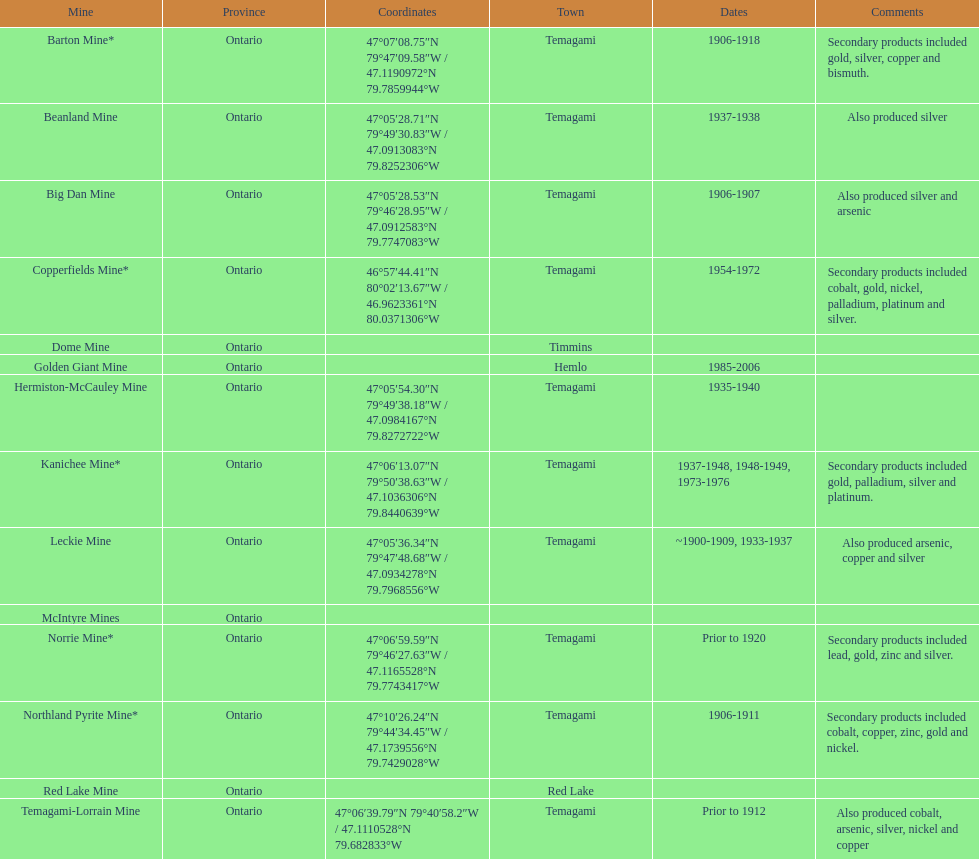Could you help me parse every detail presented in this table? {'header': ['Mine', 'Province', 'Coordinates', 'Town', 'Dates', 'Comments'], 'rows': [['Barton Mine*', 'Ontario', '47°07′08.75″N 79°47′09.58″W\ufeff / \ufeff47.1190972°N 79.7859944°W', 'Temagami', '1906-1918', 'Secondary products included gold, silver, copper and bismuth.'], ['Beanland Mine', 'Ontario', '47°05′28.71″N 79°49′30.83″W\ufeff / \ufeff47.0913083°N 79.8252306°W', 'Temagami', '1937-1938', 'Also produced silver'], ['Big Dan Mine', 'Ontario', '47°05′28.53″N 79°46′28.95″W\ufeff / \ufeff47.0912583°N 79.7747083°W', 'Temagami', '1906-1907', 'Also produced silver and arsenic'], ['Copperfields Mine*', 'Ontario', '46°57′44.41″N 80°02′13.67″W\ufeff / \ufeff46.9623361°N 80.0371306°W', 'Temagami', '1954-1972', 'Secondary products included cobalt, gold, nickel, palladium, platinum and silver.'], ['Dome Mine', 'Ontario', '', 'Timmins', '', ''], ['Golden Giant Mine', 'Ontario', '', 'Hemlo', '1985-2006', ''], ['Hermiston-McCauley Mine', 'Ontario', '47°05′54.30″N 79°49′38.18″W\ufeff / \ufeff47.0984167°N 79.8272722°W', 'Temagami', '1935-1940', ''], ['Kanichee Mine*', 'Ontario', '47°06′13.07″N 79°50′38.63″W\ufeff / \ufeff47.1036306°N 79.8440639°W', 'Temagami', '1937-1948, 1948-1949, 1973-1976', 'Secondary products included gold, palladium, silver and platinum.'], ['Leckie Mine', 'Ontario', '47°05′36.34″N 79°47′48.68″W\ufeff / \ufeff47.0934278°N 79.7968556°W', 'Temagami', '~1900-1909, 1933-1937', 'Also produced arsenic, copper and silver'], ['McIntyre Mines', 'Ontario', '', '', '', ''], ['Norrie Mine*', 'Ontario', '47°06′59.59″N 79°46′27.63″W\ufeff / \ufeff47.1165528°N 79.7743417°W', 'Temagami', 'Prior to 1920', 'Secondary products included lead, gold, zinc and silver.'], ['Northland Pyrite Mine*', 'Ontario', '47°10′26.24″N 79°44′34.45″W\ufeff / \ufeff47.1739556°N 79.7429028°W', 'Temagami', '1906-1911', 'Secondary products included cobalt, copper, zinc, gold and nickel.'], ['Red Lake Mine', 'Ontario', '', 'Red Lake', '', ''], ['Temagami-Lorrain Mine', 'Ontario', '47°06′39.79″N 79°40′58.2″W\ufeff / \ufeff47.1110528°N 79.682833°W', 'Temagami', 'Prior to 1912', 'Also produced cobalt, arsenic, silver, nickel and copper']]} What is the frequency of temagami being mentioned on the list? 10. 